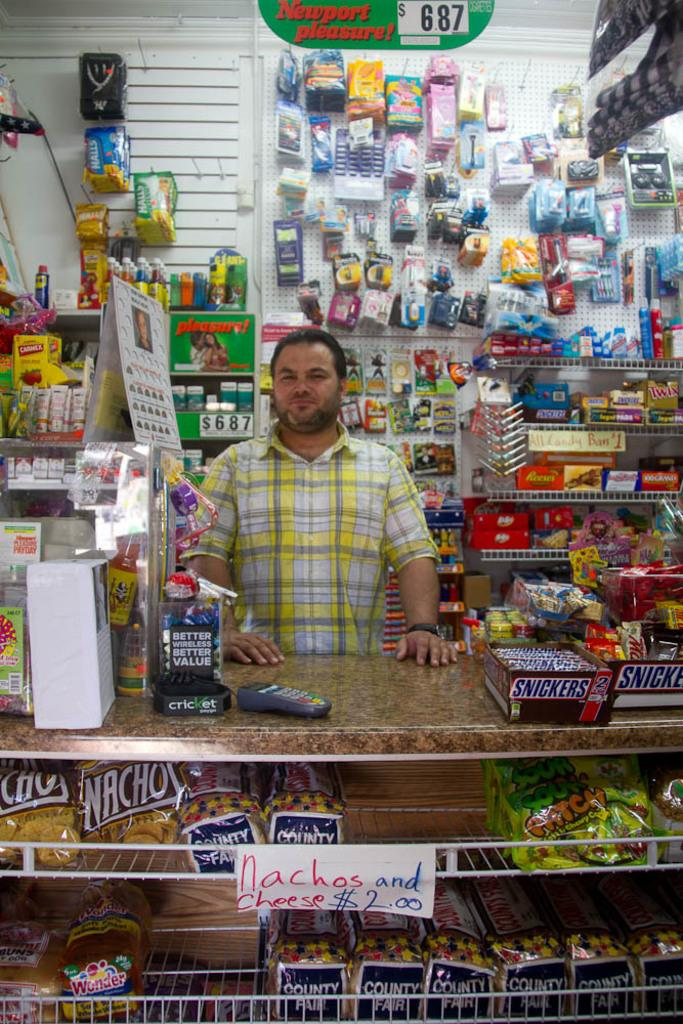<image>
Create a compact narrative representing the image presented. A man standing behind a counter has a newport pleasure sign that shows they cost &6.87 